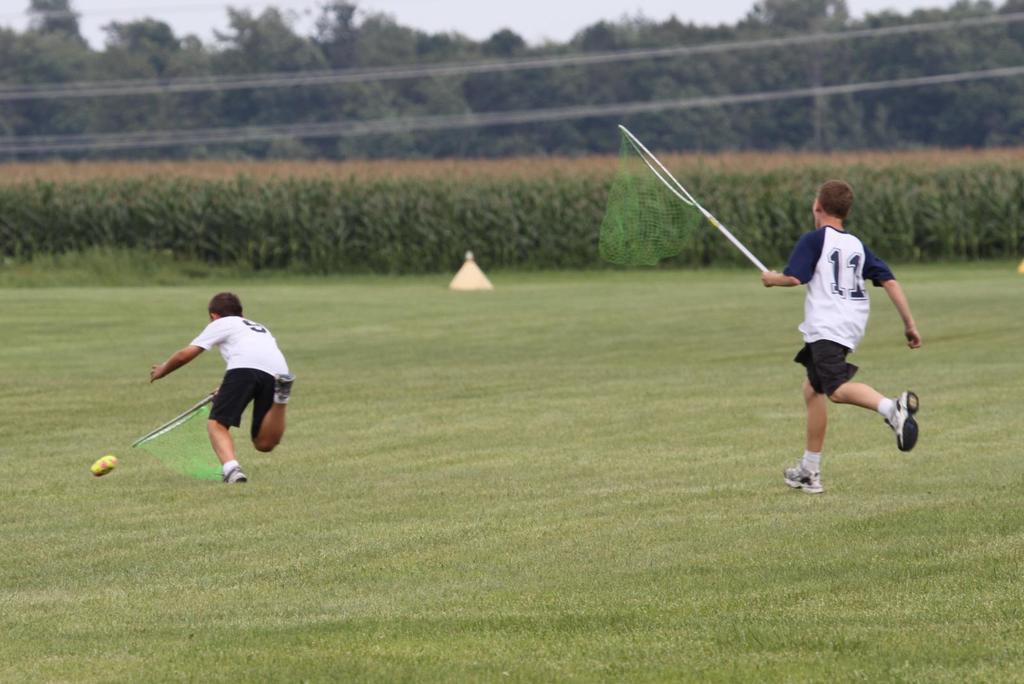In one or two sentences, can you explain what this image depicts? In the foreground of this image, there are two boys running and holding nets and also there is an object in the air above the grass land. In the background, there is an object, crops, trees, cables and the sky. 